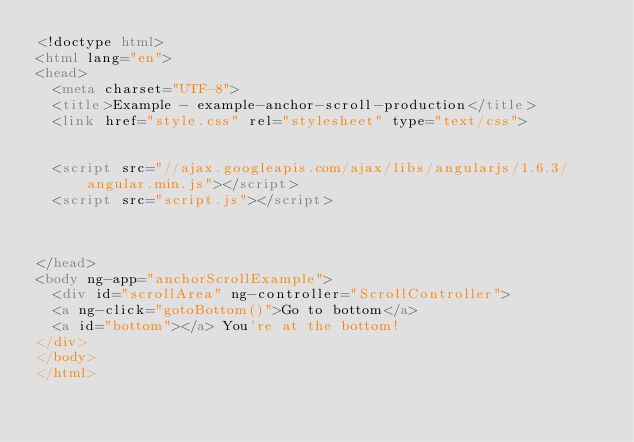<code> <loc_0><loc_0><loc_500><loc_500><_HTML_><!doctype html>
<html lang="en">
<head>
  <meta charset="UTF-8">
  <title>Example - example-anchor-scroll-production</title>
  <link href="style.css" rel="stylesheet" type="text/css">
  

  <script src="//ajax.googleapis.com/ajax/libs/angularjs/1.6.3/angular.min.js"></script>
  <script src="script.js"></script>
  

  
</head>
<body ng-app="anchorScrollExample">
  <div id="scrollArea" ng-controller="ScrollController">
  <a ng-click="gotoBottom()">Go to bottom</a>
  <a id="bottom"></a> You're at the bottom!
</div>
</body>
</html></code> 